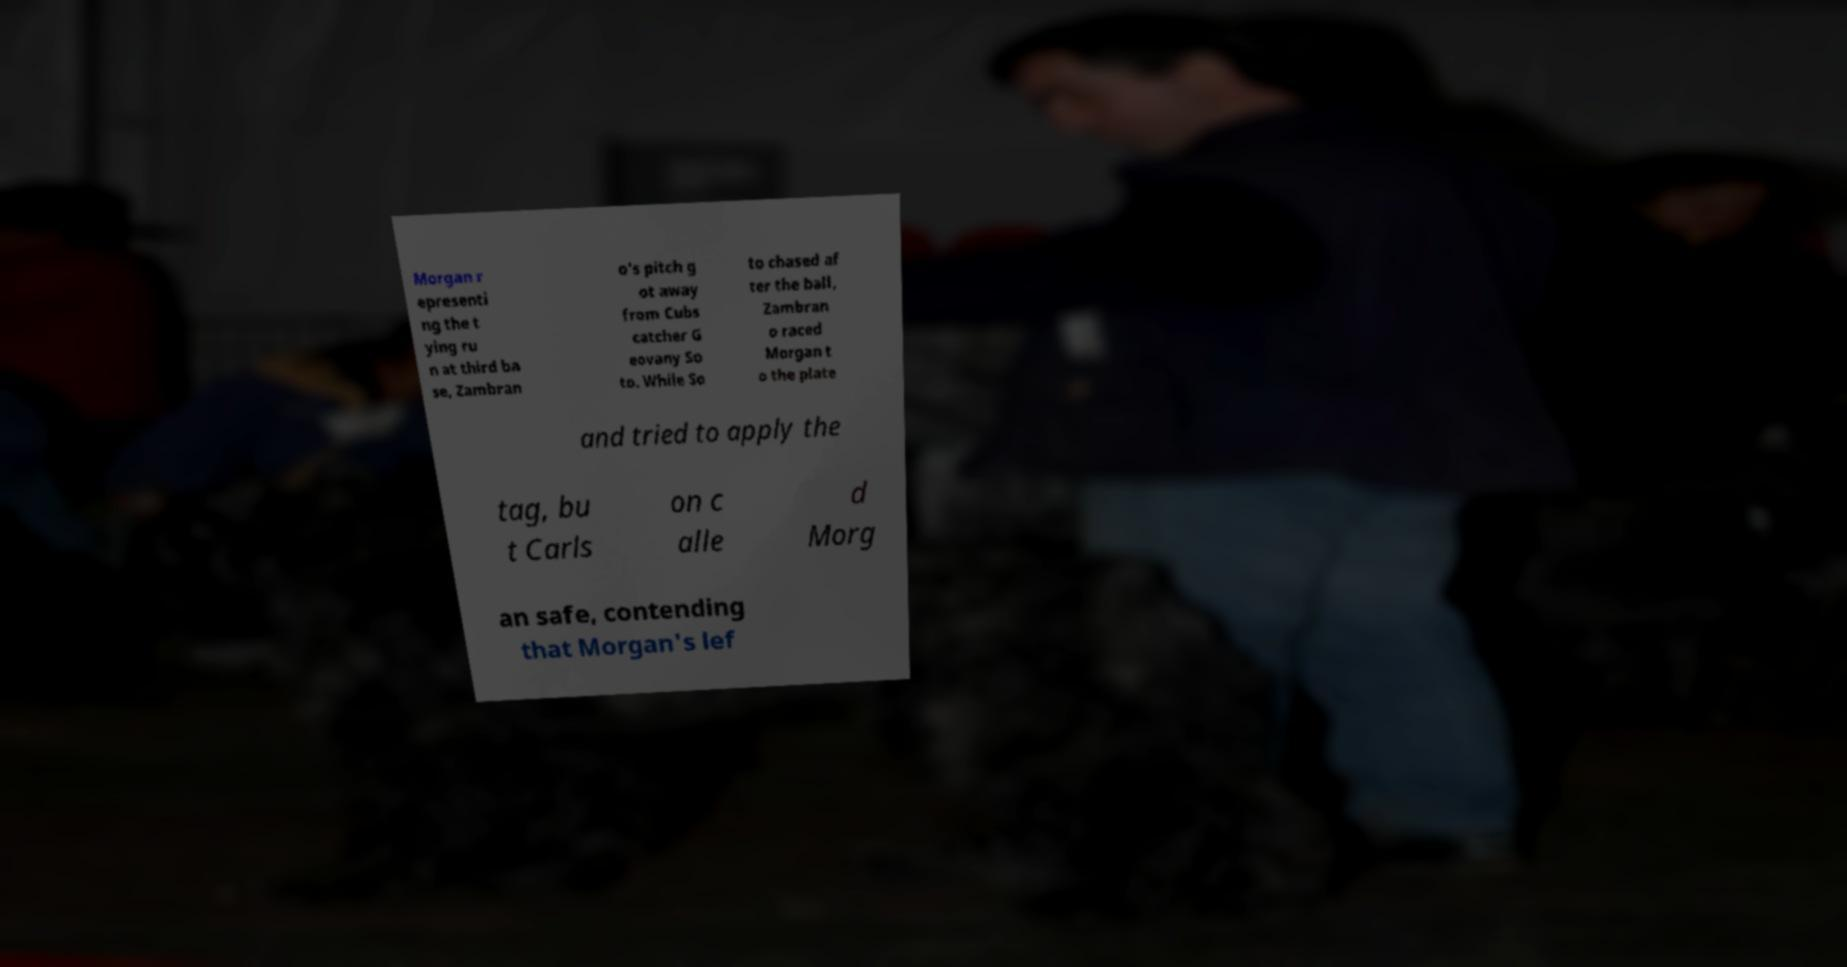Could you extract and type out the text from this image? Morgan r epresenti ng the t ying ru n at third ba se, Zambran o's pitch g ot away from Cubs catcher G eovany So to. While So to chased af ter the ball, Zambran o raced Morgan t o the plate and tried to apply the tag, bu t Carls on c alle d Morg an safe, contending that Morgan's lef 